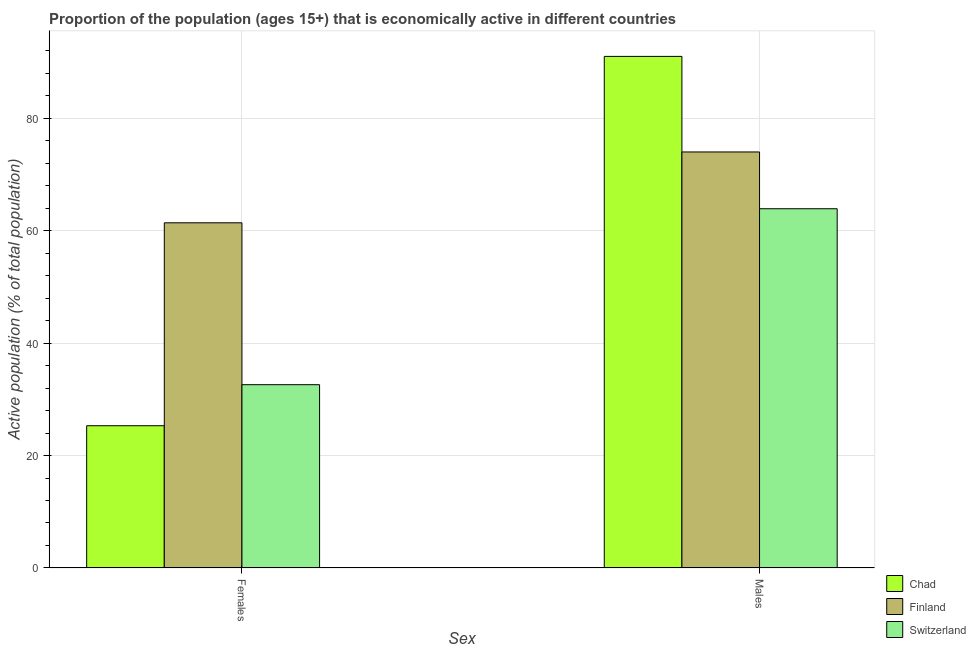How many different coloured bars are there?
Ensure brevity in your answer.  3. How many bars are there on the 2nd tick from the left?
Give a very brief answer. 3. How many bars are there on the 1st tick from the right?
Make the answer very short. 3. What is the label of the 1st group of bars from the left?
Give a very brief answer. Females. What is the percentage of economically active female population in Switzerland?
Your answer should be very brief. 32.6. Across all countries, what is the maximum percentage of economically active female population?
Provide a short and direct response. 61.4. Across all countries, what is the minimum percentage of economically active male population?
Your answer should be very brief. 63.9. In which country was the percentage of economically active male population maximum?
Make the answer very short. Chad. In which country was the percentage of economically active female population minimum?
Give a very brief answer. Chad. What is the total percentage of economically active female population in the graph?
Make the answer very short. 119.3. What is the difference between the percentage of economically active male population in Chad and that in Switzerland?
Your response must be concise. 27.1. What is the average percentage of economically active female population per country?
Your response must be concise. 39.77. What is the difference between the percentage of economically active female population and percentage of economically active male population in Switzerland?
Ensure brevity in your answer.  -31.3. In how many countries, is the percentage of economically active male population greater than 24 %?
Offer a terse response. 3. What is the ratio of the percentage of economically active female population in Switzerland to that in Chad?
Keep it short and to the point. 1.29. Is the percentage of economically active female population in Finland less than that in Switzerland?
Provide a succinct answer. No. In how many countries, is the percentage of economically active male population greater than the average percentage of economically active male population taken over all countries?
Offer a terse response. 1. What does the 1st bar from the left in Males represents?
Offer a very short reply. Chad. Are all the bars in the graph horizontal?
Give a very brief answer. No. How many countries are there in the graph?
Your answer should be very brief. 3. What is the difference between two consecutive major ticks on the Y-axis?
Provide a short and direct response. 20. Are the values on the major ticks of Y-axis written in scientific E-notation?
Offer a very short reply. No. Where does the legend appear in the graph?
Keep it short and to the point. Bottom right. What is the title of the graph?
Your response must be concise. Proportion of the population (ages 15+) that is economically active in different countries. What is the label or title of the X-axis?
Provide a succinct answer. Sex. What is the label or title of the Y-axis?
Your answer should be compact. Active population (% of total population). What is the Active population (% of total population) of Chad in Females?
Your response must be concise. 25.3. What is the Active population (% of total population) of Finland in Females?
Offer a very short reply. 61.4. What is the Active population (% of total population) in Switzerland in Females?
Give a very brief answer. 32.6. What is the Active population (% of total population) in Chad in Males?
Your response must be concise. 91. What is the Active population (% of total population) of Switzerland in Males?
Offer a terse response. 63.9. Across all Sex, what is the maximum Active population (% of total population) in Chad?
Offer a very short reply. 91. Across all Sex, what is the maximum Active population (% of total population) of Switzerland?
Your answer should be compact. 63.9. Across all Sex, what is the minimum Active population (% of total population) in Chad?
Provide a short and direct response. 25.3. Across all Sex, what is the minimum Active population (% of total population) in Finland?
Ensure brevity in your answer.  61.4. Across all Sex, what is the minimum Active population (% of total population) in Switzerland?
Provide a short and direct response. 32.6. What is the total Active population (% of total population) in Chad in the graph?
Give a very brief answer. 116.3. What is the total Active population (% of total population) of Finland in the graph?
Provide a short and direct response. 135.4. What is the total Active population (% of total population) of Switzerland in the graph?
Offer a terse response. 96.5. What is the difference between the Active population (% of total population) in Chad in Females and that in Males?
Your response must be concise. -65.7. What is the difference between the Active population (% of total population) of Switzerland in Females and that in Males?
Your answer should be very brief. -31.3. What is the difference between the Active population (% of total population) in Chad in Females and the Active population (% of total population) in Finland in Males?
Your answer should be compact. -48.7. What is the difference between the Active population (% of total population) of Chad in Females and the Active population (% of total population) of Switzerland in Males?
Make the answer very short. -38.6. What is the average Active population (% of total population) of Chad per Sex?
Make the answer very short. 58.15. What is the average Active population (% of total population) of Finland per Sex?
Give a very brief answer. 67.7. What is the average Active population (% of total population) in Switzerland per Sex?
Keep it short and to the point. 48.25. What is the difference between the Active population (% of total population) in Chad and Active population (% of total population) in Finland in Females?
Your answer should be very brief. -36.1. What is the difference between the Active population (% of total population) in Chad and Active population (% of total population) in Switzerland in Females?
Your response must be concise. -7.3. What is the difference between the Active population (% of total population) of Finland and Active population (% of total population) of Switzerland in Females?
Your answer should be very brief. 28.8. What is the difference between the Active population (% of total population) in Chad and Active population (% of total population) in Switzerland in Males?
Keep it short and to the point. 27.1. What is the ratio of the Active population (% of total population) of Chad in Females to that in Males?
Make the answer very short. 0.28. What is the ratio of the Active population (% of total population) in Finland in Females to that in Males?
Make the answer very short. 0.83. What is the ratio of the Active population (% of total population) in Switzerland in Females to that in Males?
Make the answer very short. 0.51. What is the difference between the highest and the second highest Active population (% of total population) in Chad?
Make the answer very short. 65.7. What is the difference between the highest and the second highest Active population (% of total population) of Switzerland?
Offer a terse response. 31.3. What is the difference between the highest and the lowest Active population (% of total population) of Chad?
Offer a terse response. 65.7. What is the difference between the highest and the lowest Active population (% of total population) in Finland?
Ensure brevity in your answer.  12.6. What is the difference between the highest and the lowest Active population (% of total population) of Switzerland?
Keep it short and to the point. 31.3. 